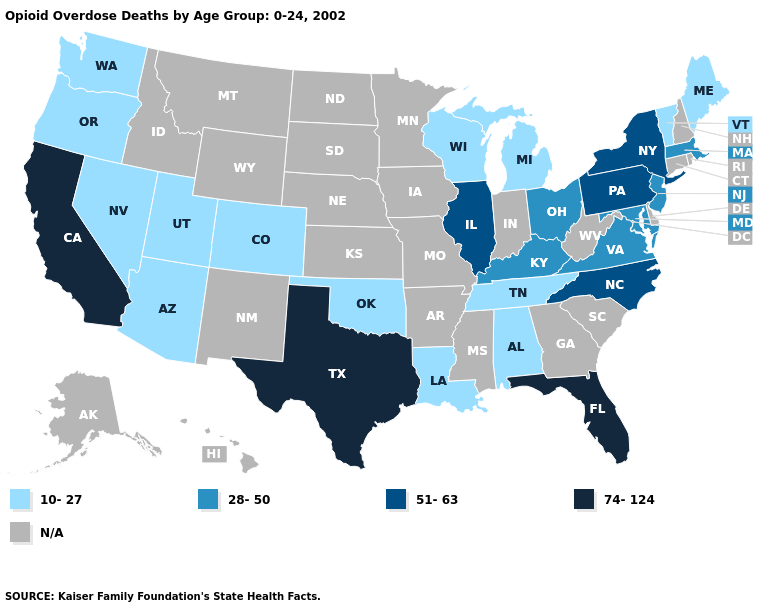Which states have the highest value in the USA?
Keep it brief. California, Florida, Texas. How many symbols are there in the legend?
Be succinct. 5. Name the states that have a value in the range 10-27?
Give a very brief answer. Alabama, Arizona, Colorado, Louisiana, Maine, Michigan, Nevada, Oklahoma, Oregon, Tennessee, Utah, Vermont, Washington, Wisconsin. What is the lowest value in states that border California?
Write a very short answer. 10-27. What is the value of Iowa?
Write a very short answer. N/A. What is the lowest value in states that border Arkansas?
Short answer required. 10-27. What is the value of Florida?
Write a very short answer. 74-124. Does the map have missing data?
Concise answer only. Yes. Name the states that have a value in the range 74-124?
Give a very brief answer. California, Florida, Texas. Which states hav the highest value in the West?
Short answer required. California. What is the highest value in states that border Connecticut?
Concise answer only. 51-63. Among the states that border Texas , which have the lowest value?
Give a very brief answer. Louisiana, Oklahoma. What is the value of Pennsylvania?
Keep it brief. 51-63. 